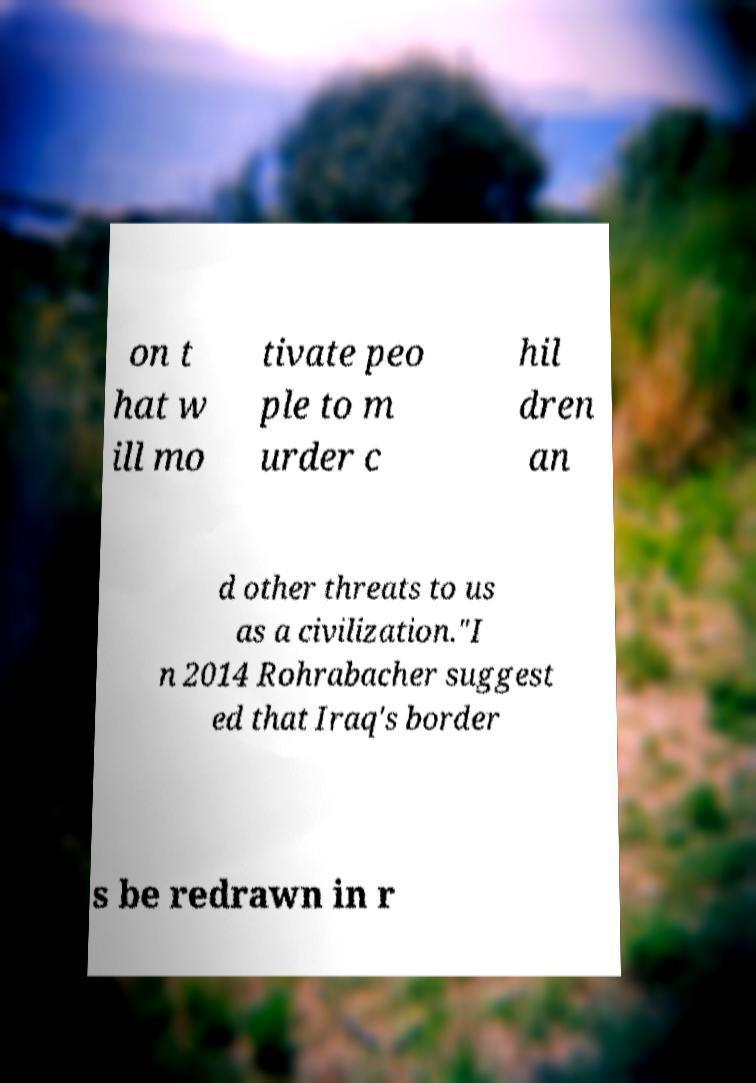What messages or text are displayed in this image? I need them in a readable, typed format. on t hat w ill mo tivate peo ple to m urder c hil dren an d other threats to us as a civilization."I n 2014 Rohrabacher suggest ed that Iraq's border s be redrawn in r 